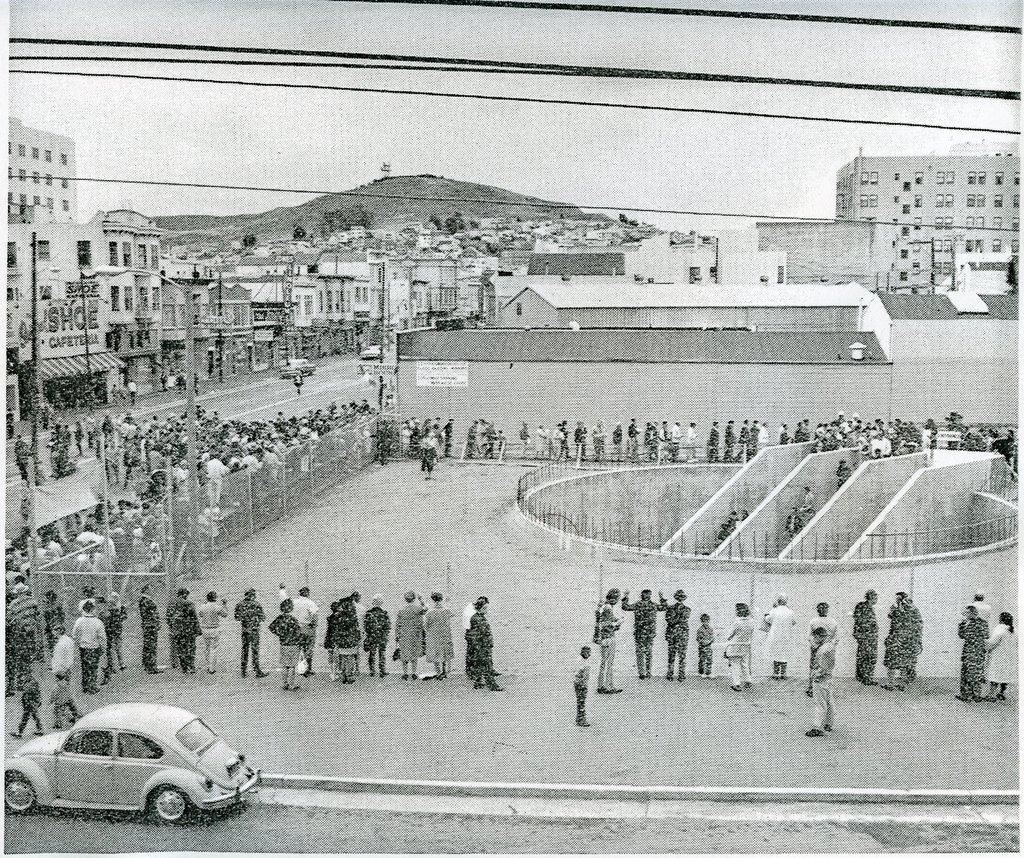Please provide a concise description of this image. In this image I can see a well in the middle and there is a fence and in front of fence there are crowd of people visible and there are building , poles, road visible in the middle at the top I can see the sky. I can see a vehicle at the bottom. 